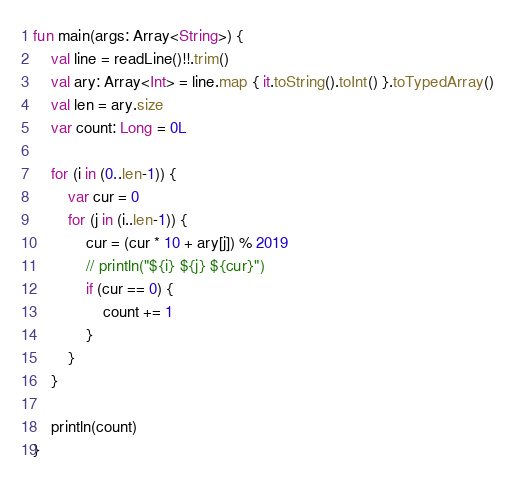<code> <loc_0><loc_0><loc_500><loc_500><_Kotlin_>fun main(args: Array<String>) {
    val line = readLine()!!.trim()
    val ary: Array<Int> = line.map { it.toString().toInt() }.toTypedArray()
    val len = ary.size
    var count: Long = 0L

    for (i in (0..len-1)) {
        var cur = 0
        for (j in (i..len-1)) {
            cur = (cur * 10 + ary[j]) % 2019
            // println("${i} ${j} ${cur}")
            if (cur == 0) {
                count += 1
            }
        }
    }

    println(count)
}</code> 